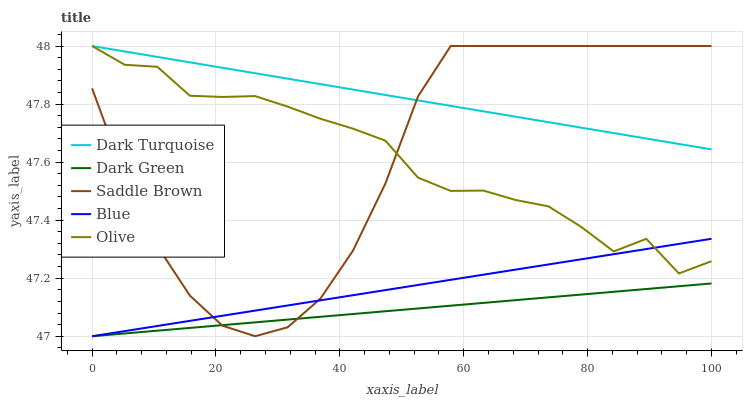Does Dark Green have the minimum area under the curve?
Answer yes or no. Yes. Does Dark Turquoise have the maximum area under the curve?
Answer yes or no. Yes. Does Olive have the minimum area under the curve?
Answer yes or no. No. Does Olive have the maximum area under the curve?
Answer yes or no. No. Is Dark Turquoise the smoothest?
Answer yes or no. Yes. Is Olive the roughest?
Answer yes or no. Yes. Is Olive the smoothest?
Answer yes or no. No. Is Dark Turquoise the roughest?
Answer yes or no. No. Does Olive have the lowest value?
Answer yes or no. No. Does Saddle Brown have the highest value?
Answer yes or no. Yes. Does Dark Green have the highest value?
Answer yes or no. No. Is Dark Green less than Olive?
Answer yes or no. Yes. Is Dark Turquoise greater than Dark Green?
Answer yes or no. Yes. Does Saddle Brown intersect Dark Turquoise?
Answer yes or no. Yes. Is Saddle Brown less than Dark Turquoise?
Answer yes or no. No. Is Saddle Brown greater than Dark Turquoise?
Answer yes or no. No. Does Dark Green intersect Olive?
Answer yes or no. No. 